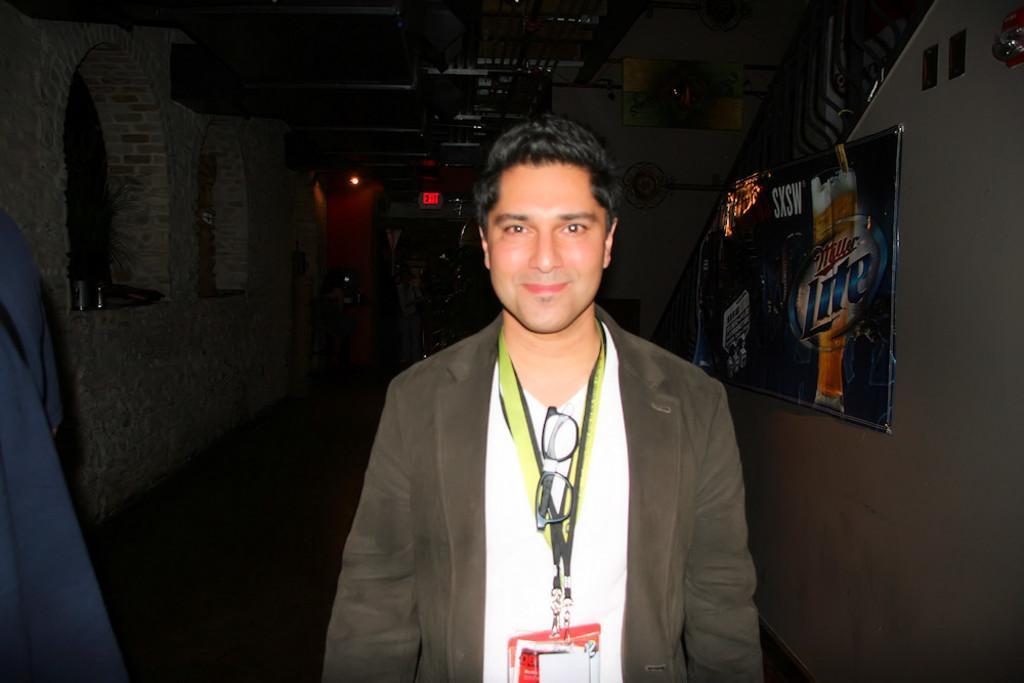Can you describe this image briefly? This is the man standing and smiling. He wore a suit, T-shirt and tags. This looks like a frame, which is attached to the wall. I think this is the ceiling. On the left side of the image, that looks like a cloth. In the background, I can see an exit board, which is attached to the wall. 